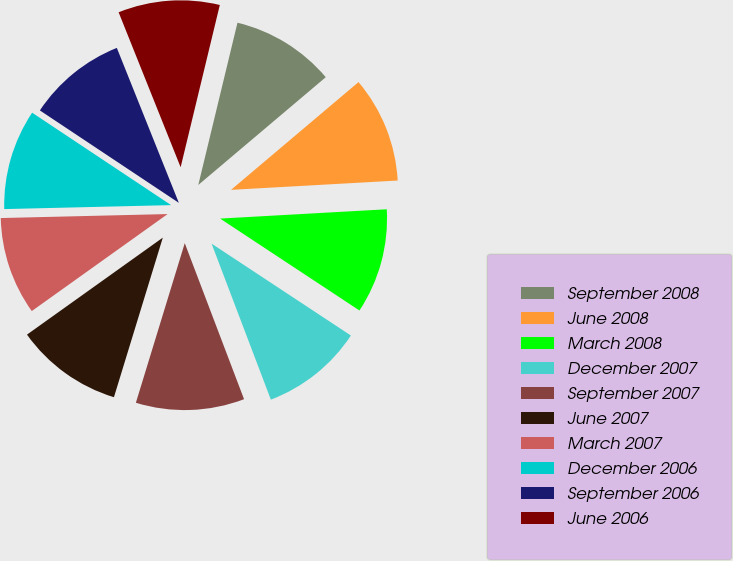Convert chart to OTSL. <chart><loc_0><loc_0><loc_500><loc_500><pie_chart><fcel>September 2008<fcel>June 2008<fcel>March 2008<fcel>December 2007<fcel>September 2007<fcel>June 2007<fcel>March 2007<fcel>December 2006<fcel>September 2006<fcel>June 2006<nl><fcel>10.06%<fcel>10.28%<fcel>10.17%<fcel>9.94%<fcel>10.51%<fcel>10.4%<fcel>9.49%<fcel>9.72%<fcel>9.6%<fcel>9.83%<nl></chart> 